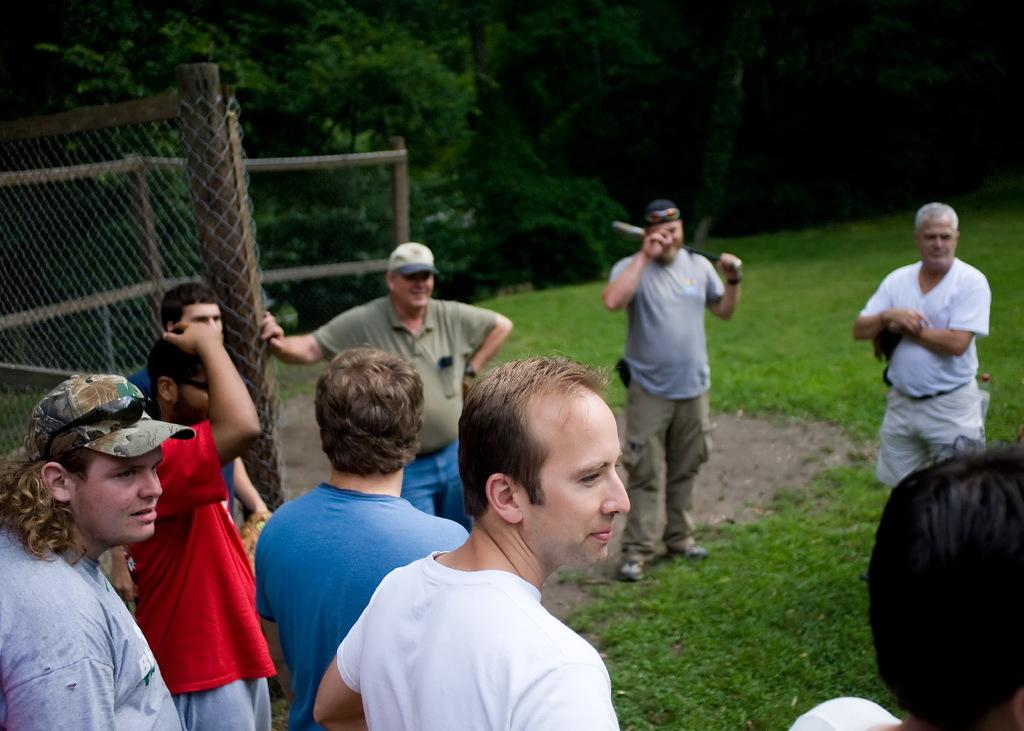How many people are in the image? There is a group of people in the image, but the exact number is not specified. Where are the people standing? The people are standing on the grass in the image. What can be seen in the background of the image? There are trees in the background of the image. What is the purpose of the fence in the image? The purpose of the fence is not specified, but it is present in the image. What type of match is being played in the image? There is no match being played in the image; it features a group of people standing on the grass with a fence and trees in the background. 